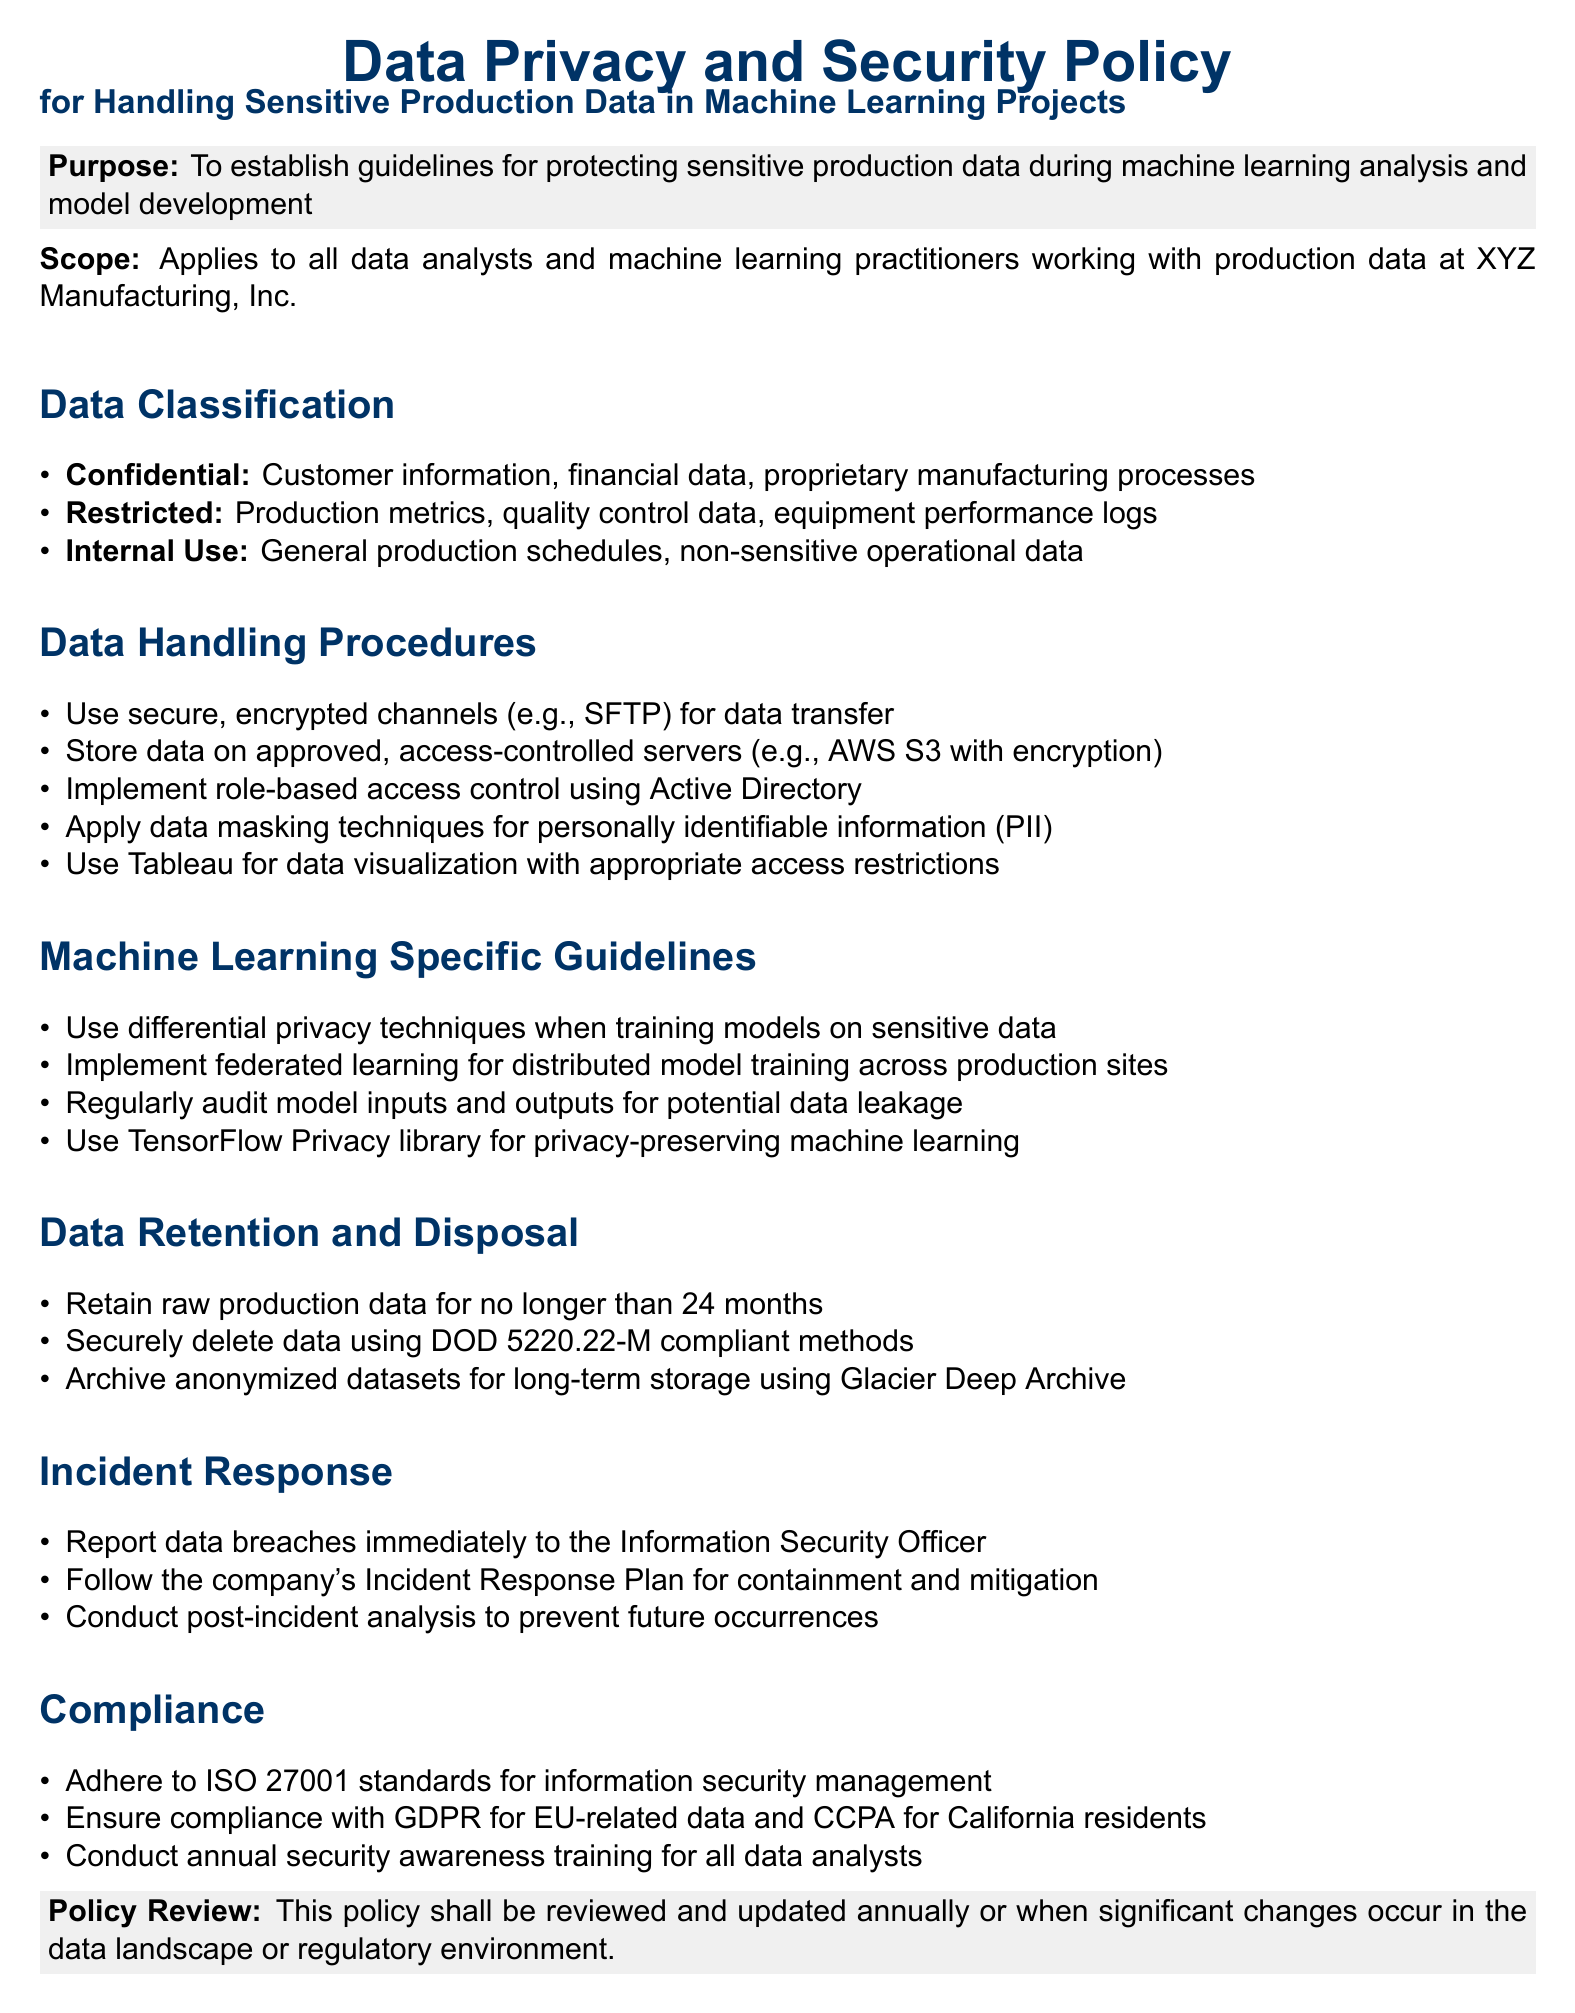What is the purpose of the document? The purpose is to establish guidelines for protecting sensitive production data during machine learning analysis and model development.
Answer: To establish guidelines for protecting sensitive production data during machine learning analysis and model development What are the three data classification levels mentioned? The document lists three levels of data classification: Confidential, Restricted, and Internal Use.
Answer: Confidential, Restricted, Internal Use How long can raw production data be retained? The policy stipulates that raw production data retention should not exceed a specific time frame.
Answer: 24 months Who should be reported to in case of a data breach? The document outlines a specific role responsible for responding to data breaches.
Answer: Information Security Officer What technique is suggested for training models on sensitive data? The guidelines specify a particular method to enhance privacy during model training.
Answer: Differential privacy What is required for compliance with EU-related data? The document provides a specific compliance regulation that must be adhered to for data related to Europe.
Answer: GDPR What method should be used for securely deleting data? The policy describes a standard that outlines how to securely dispose of data.
Answer: DOD 5220.22-M compliant methods How often should security awareness training be conducted? The frequency of mandatory training for data analysts is specified in the document.
Answer: Annually What tool is recommended for privacy-preserving machine learning? The document suggests a specific library to be used for maintaining privacy in machine learning.
Answer: TensorFlow Privacy library 